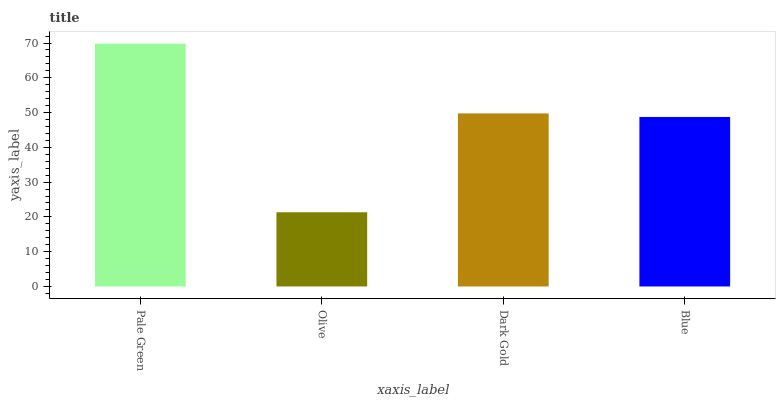Is Olive the minimum?
Answer yes or no. Yes. Is Pale Green the maximum?
Answer yes or no. Yes. Is Dark Gold the minimum?
Answer yes or no. No. Is Dark Gold the maximum?
Answer yes or no. No. Is Dark Gold greater than Olive?
Answer yes or no. Yes. Is Olive less than Dark Gold?
Answer yes or no. Yes. Is Olive greater than Dark Gold?
Answer yes or no. No. Is Dark Gold less than Olive?
Answer yes or no. No. Is Dark Gold the high median?
Answer yes or no. Yes. Is Blue the low median?
Answer yes or no. Yes. Is Olive the high median?
Answer yes or no. No. Is Olive the low median?
Answer yes or no. No. 